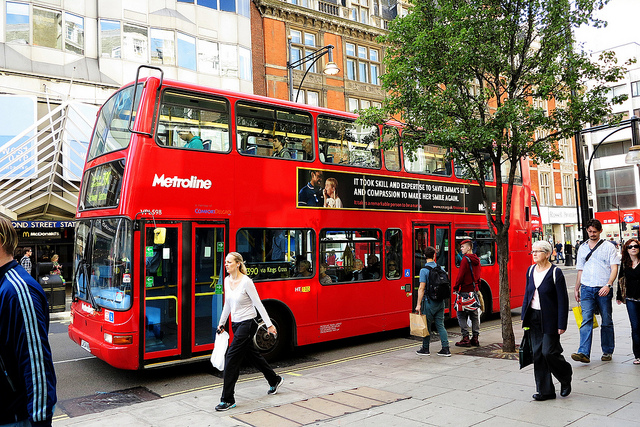Please transcribe the text in this image. Metrolline AND COMPASSION 10 SKILL m STAT TSTREER 